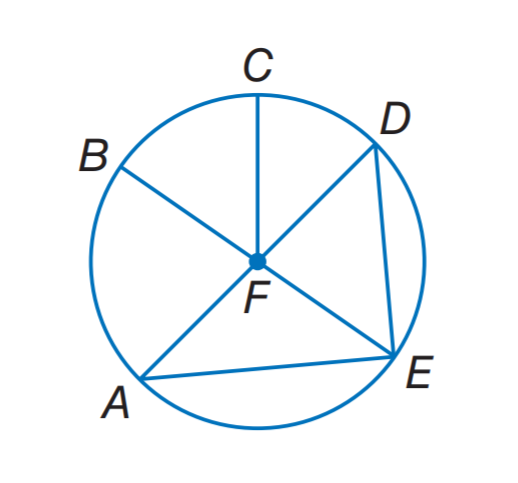Question: In \odot F, if D A = 7.4, what is E F?
Choices:
A. 3.7
B. 7.4
C. 11.1
D. 14.8
Answer with the letter. Answer: A 